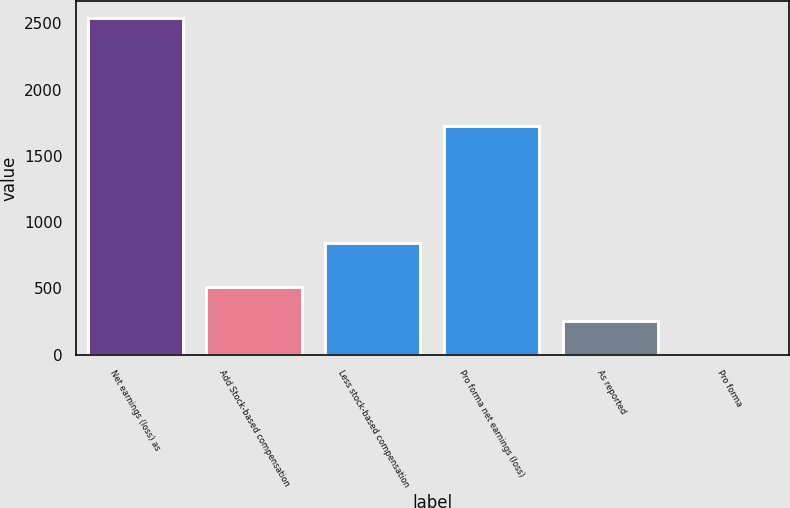Convert chart. <chart><loc_0><loc_0><loc_500><loc_500><bar_chart><fcel>Net earnings (loss) as<fcel>Add Stock-based compensation<fcel>Less stock-based compensation<fcel>Pro forma net earnings (loss)<fcel>As reported<fcel>Pro forma<nl><fcel>2539<fcel>508.25<fcel>844<fcel>1725<fcel>254.41<fcel>0.57<nl></chart> 